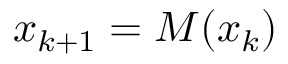Convert formula to latex. <formula><loc_0><loc_0><loc_500><loc_500>x _ { k + 1 } = M ( x _ { k } )</formula> 